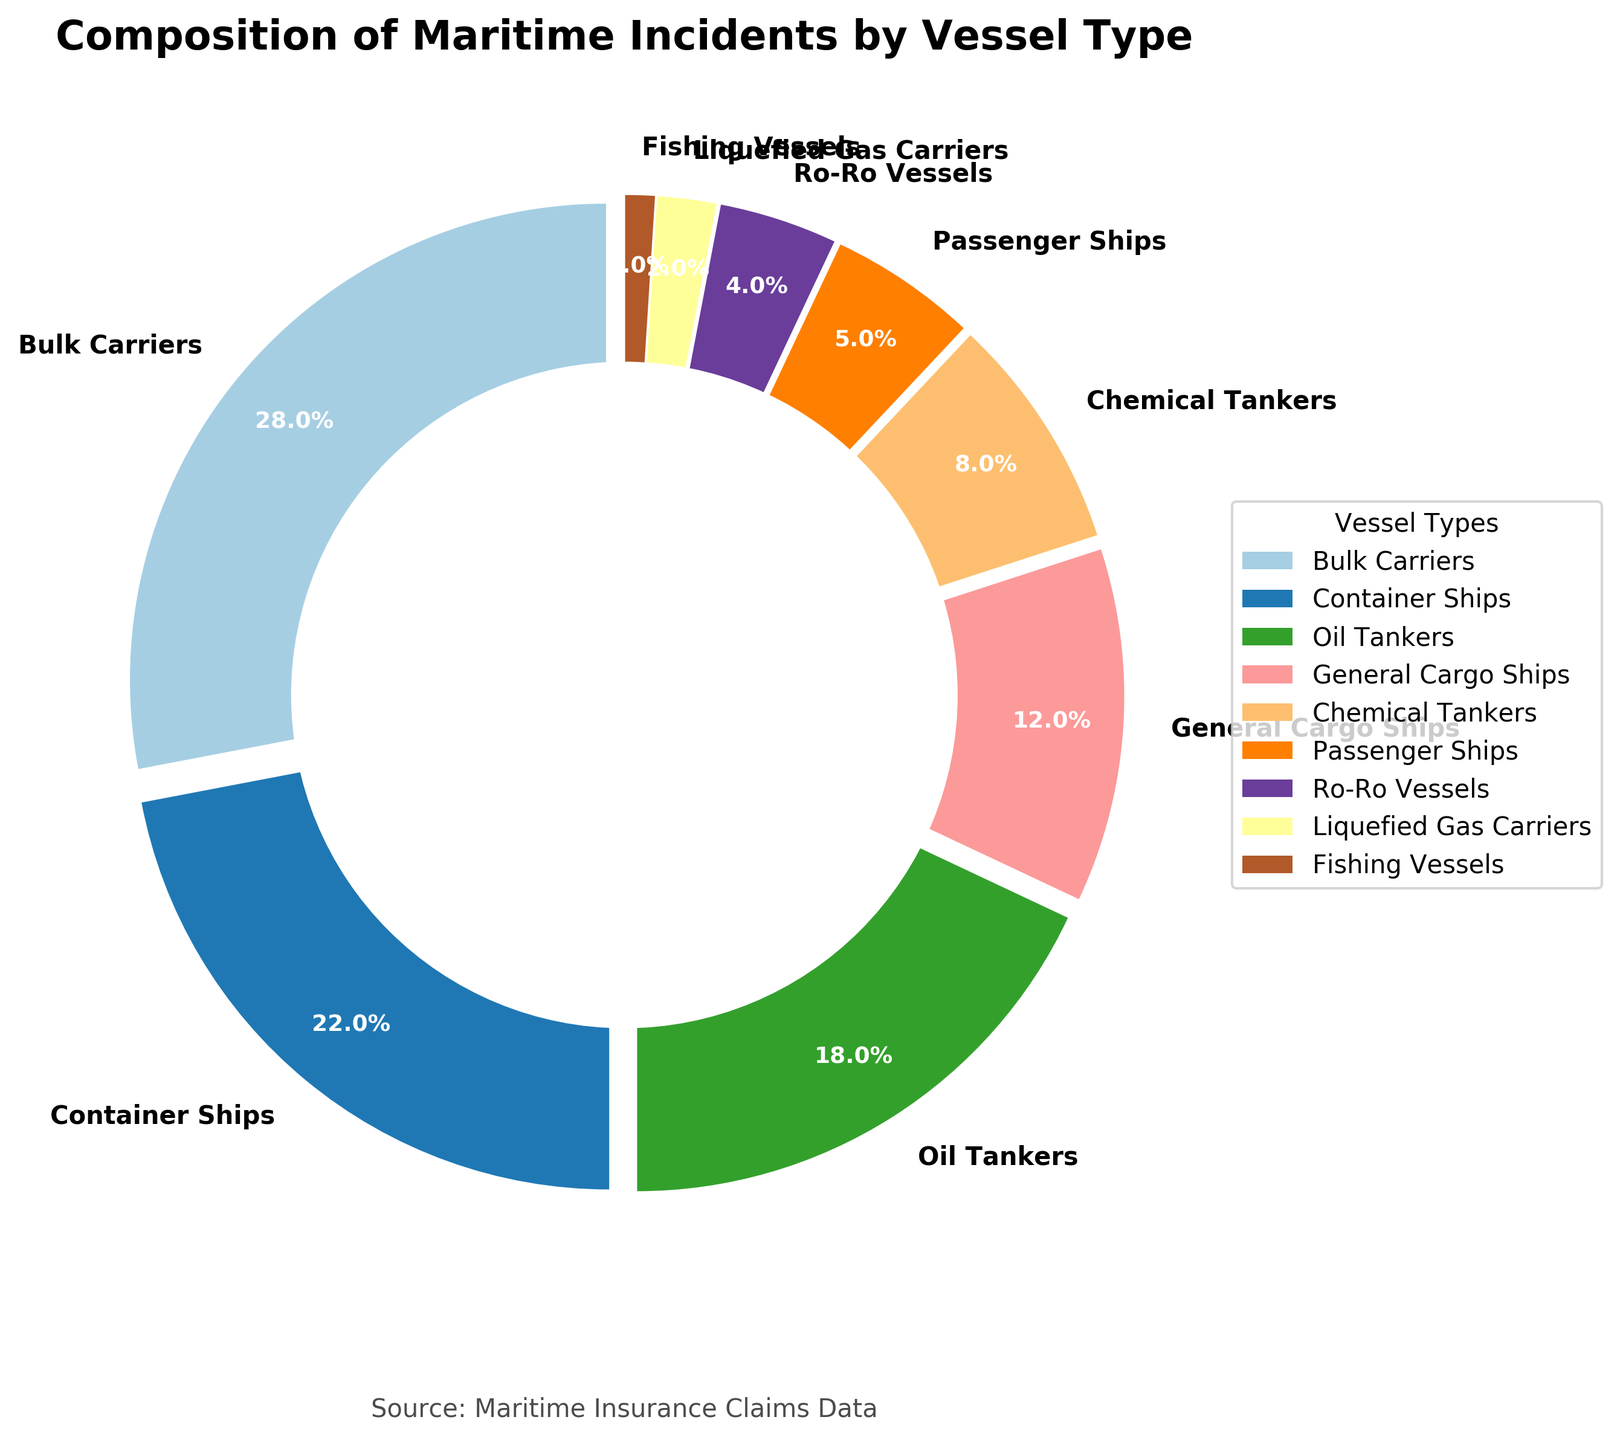What's the most common vessel type involved in maritime incidents leading to insurance claims? Look at the slices of the pie chart and find the one with the largest percentage. Bulk Carriers have the largest segment with 28%.
Answer: Bulk Carriers Which vessel type is the least common in causing insurance claims? Find the segment with the smallest proportion. Fishing Vessels have the smallest segment with 1%.
Answer: Fishing Vessels What is the combined percentage of incidents involving oil tankers and chemical tankers? Add the percentages of Oil Tankers (18%) and Chemical Tankers (8%). 18% + 8% equals 26%.
Answer: 26% Is the proportion of incidents involving General Cargo Ships greater than that of Passenger Ships and Liquefied Gas Carriers combined? Combine the percentages of Passenger Ships (5%) and Liquefied Gas Carriers (2%)—5% + 2% equals 7%—and compare it with the percentage of General Cargo Ships (12%). 12% is indeed greater than 7%.
Answer: Yes How does the percentage of incidents involving Ro-Ro Vessels compare to that of Fishing Vessels? Compare the percentages of Ro-Ro Vessels (4%) and Fishing Vessels (1%). Ro-Ro Vessels have a higher percentage.
Answer: Greater What proportion of incidents is explained by the three most common vessel types? Sum the percentages of the three largest segments: Bulk Carriers (28%), Container Ships (22%), and Oil Tankers (18%). 28% + 22% + 18% equals 68%.
Answer: 68% Which segment of the pie chart is represented by the color green (assuming it is visible)? In the absence of exact color coding in the data given, we cannot determine the specific segment noted as green. A visual inspection would be required.
Answer: Cannot determine Among Bulk Carriers and Container Ships, which category contributes the most incidents, and by how much? Compare the percentages of Bulk Carriers (28%) and Container Ships (22%). The difference is 28% - 22% = 6%.
Answer: Bulk Carriers, 6% What percentage of incidents involve Passenger Ships, Ro-Ro Vessels, and Liquefied Gas Carriers combined? Sum the percentages of Passenger Ships (5%), Ro-Ro Vessels (4%), and Liquefied Gas Carriers (2%). 5% + 4% + 2% equals 11%.
Answer: 11% If you group General Cargo Ships and Container Ships together, how does their combined percentage compare to Bulk Carriers? Combine the percentages of General Cargo Ships (12%) and Container Ships (22%)—12% + 22% equals 34%—and compare it to 28% for Bulk Carriers. 34% is greater than 28%.
Answer: Greater 